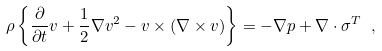<formula> <loc_0><loc_0><loc_500><loc_500>\rho \left \{ \frac { \partial } { \partial t } v + \frac { 1 } { 2 } \nabla v ^ { 2 } - v \times ( \nabla \times v ) \right \} = - \nabla p + \nabla \cdot \sigma ^ { T } \ ,</formula> 